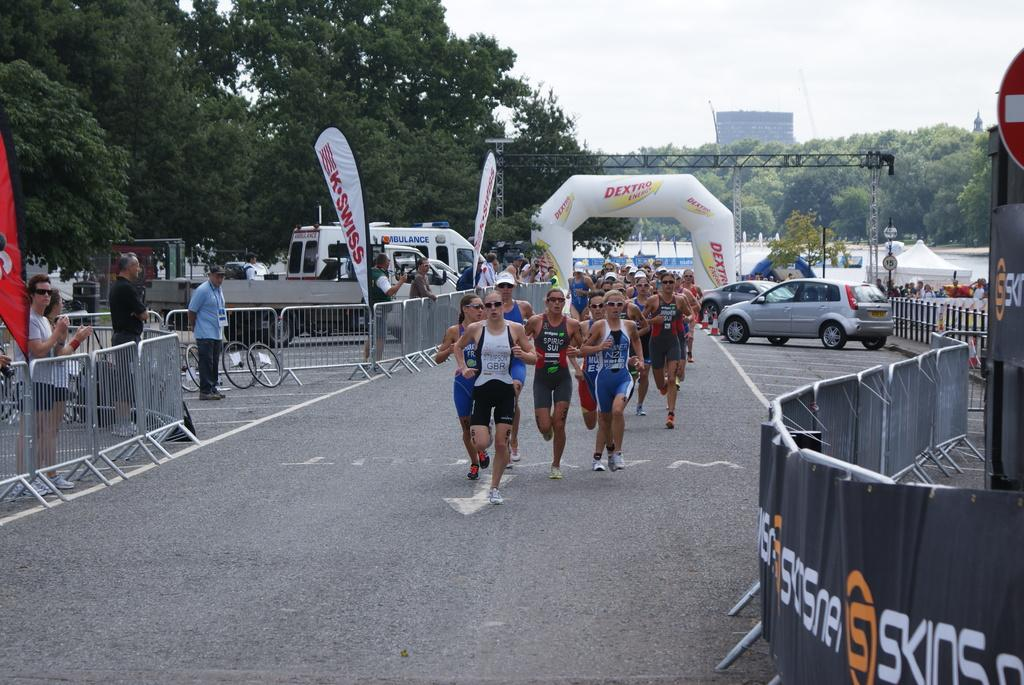What are the girls in the image doing? There is a group of girls running on the road in the image. Where are the girls located in the image? The girls are in the middle of the image. What can be seen on the right side of the image? There are parked cars on the right side of the image. What type of vegetation is on the left side of the image? There are green trees on the left side of the image. Is there any smoke coming from the cars in the image? There is no mention of smoke in the image, and the cars are parked, so it is unlikely that there would be any smoke coming from them. 